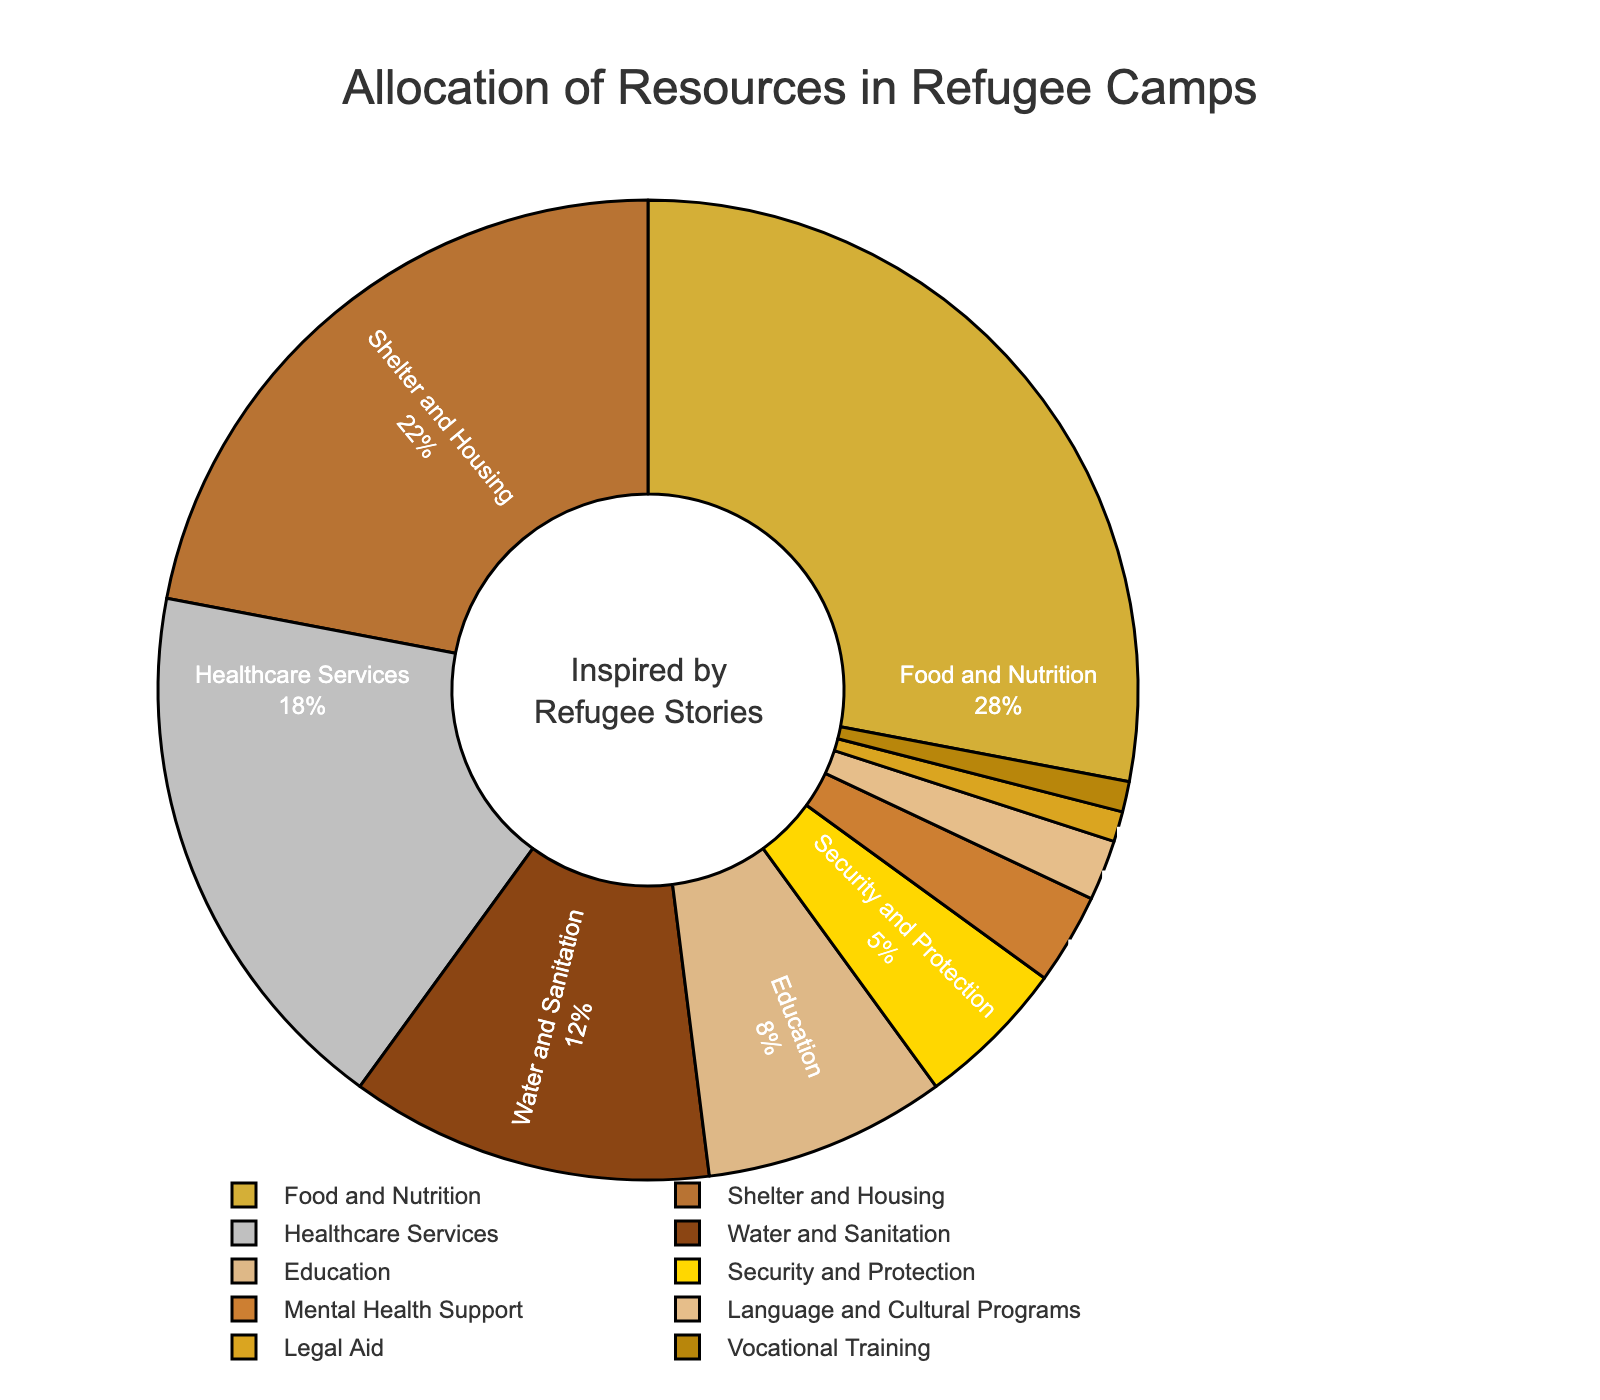What percentage of total resources is allocated to Shelter and Housing? Shelter and Housing is listed with 22% in the pie chart.
Answer: 22% Which category receives the most resources? The category with the highest percentage is Food and Nutrition at 28%.
Answer: Food and Nutrition How much more is allocated to Food and Nutrition compared to Education? Food and Nutrition gets 28%, and Education gets 8%. The difference is 28% - 8% = 20%.
Answer: 20% What is the combined allocation for Legal Aid and Vocational Training? Both Legal Aid and Vocational Training are at 1% each, so the combined allocation is 1% + 1% = 2%.
Answer: 2% Compare the allocation for Healthcare Services and Water and Sanitation. Which category gets more and by how much? Healthcare Services receives 18%, and Water and Sanitation gets 12%. Healthcare Services gets more by 18% - 12% = 6%.
Answer: Healthcare Services by 6% What is the total percentage allocation for categories related to mental well-being (including Mental Health Support and Education)? Mental Health Support is allocated 3%, and Education is 8%. The total is 3% + 8% = 11%.
Answer: 11% Which category has the least resource allocation? Legal Aid and Vocational Training both have the smallest allocation at 1% each.
Answer: Legal Aid, Vocational Training How many categories have an allocation of less than 10%? Water and Sanitation, Education, Security and Protection, Mental Health Support, Language and Cultural Programs, Legal Aid, and Vocational Training are less than 10%.
Answer: 7 What are the combined allocations for both Food and Nutrition and Shelter and Housing? Food and Nutrition is at 28%, and Shelter and Housing is at 22%. The combined allocation is 28% + 22% = 50%.
Answer: 50% Compare the allocation for Education, Security and Protection, and Language and Cultural Programs. Arrange them from highest to lowest. Education is at 8%, Security and Protection at 5%, and Language and Cultural Programs at 2%. Arranging them from highest to lowest is 8% (Education), 5% (Security and Protection), 2% (Language and Cultural Programs).
Answer: Education, Security and Protection, Language and Cultural Programs 